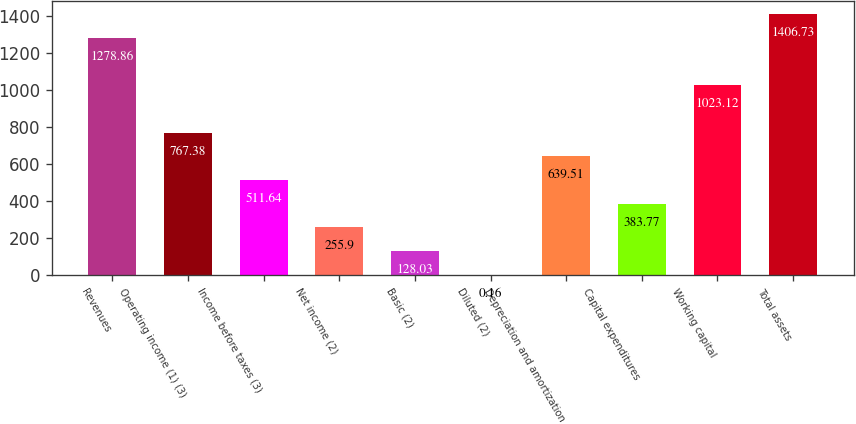Convert chart to OTSL. <chart><loc_0><loc_0><loc_500><loc_500><bar_chart><fcel>Revenues<fcel>Operating income (1) (3)<fcel>Income before taxes (3)<fcel>Net income (2)<fcel>Basic (2)<fcel>Diluted (2)<fcel>Depreciation and amortization<fcel>Capital expenditures<fcel>Working capital<fcel>Total assets<nl><fcel>1278.86<fcel>767.38<fcel>511.64<fcel>255.9<fcel>128.03<fcel>0.16<fcel>639.51<fcel>383.77<fcel>1023.12<fcel>1406.73<nl></chart> 